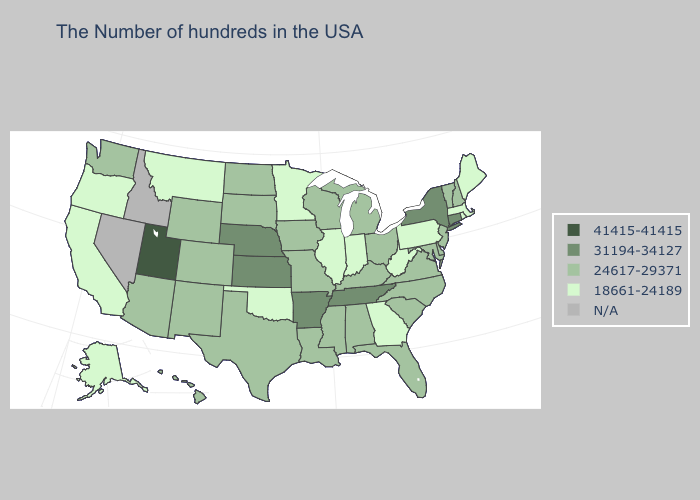Among the states that border Mississippi , which have the lowest value?
Quick response, please. Alabama, Louisiana. Among the states that border New York , does New Jersey have the lowest value?
Be succinct. No. What is the lowest value in states that border Iowa?
Give a very brief answer. 18661-24189. Is the legend a continuous bar?
Write a very short answer. No. Name the states that have a value in the range 31194-34127?
Concise answer only. Connecticut, New York, Tennessee, Arkansas, Kansas, Nebraska. Name the states that have a value in the range 18661-24189?
Write a very short answer. Maine, Massachusetts, Rhode Island, Pennsylvania, West Virginia, Georgia, Indiana, Illinois, Minnesota, Oklahoma, Montana, California, Oregon, Alaska. What is the value of Massachusetts?
Answer briefly. 18661-24189. Does the map have missing data?
Write a very short answer. Yes. What is the value of Hawaii?
Concise answer only. 24617-29371. What is the value of Nevada?
Keep it brief. N/A. Does South Carolina have the lowest value in the USA?
Answer briefly. No. What is the lowest value in the USA?
Write a very short answer. 18661-24189. Which states have the lowest value in the USA?
Answer briefly. Maine, Massachusetts, Rhode Island, Pennsylvania, West Virginia, Georgia, Indiana, Illinois, Minnesota, Oklahoma, Montana, California, Oregon, Alaska. 